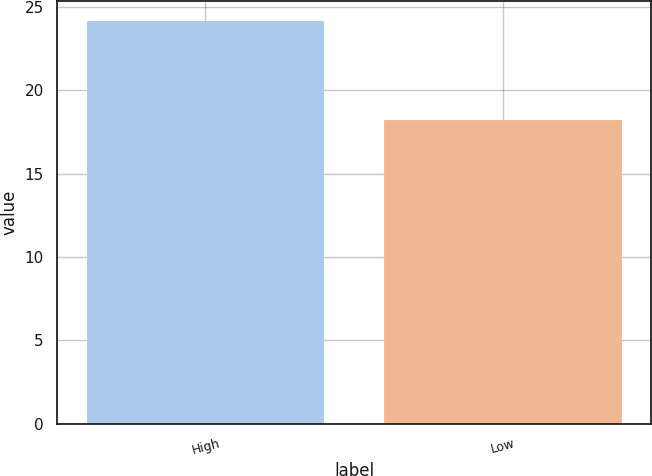Convert chart to OTSL. <chart><loc_0><loc_0><loc_500><loc_500><bar_chart><fcel>High<fcel>Low<nl><fcel>24.15<fcel>18.2<nl></chart> 